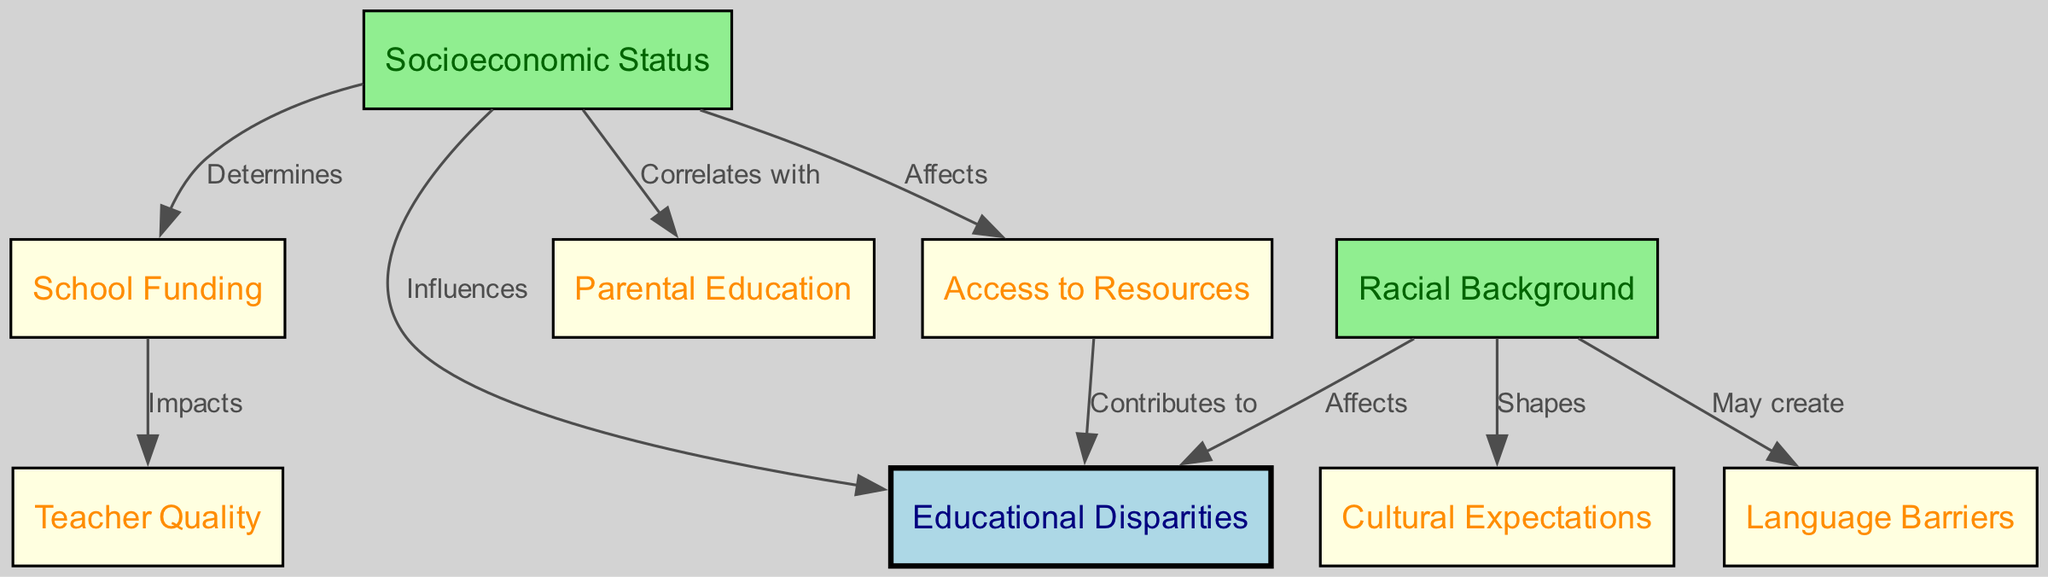What is the central theme of the diagram? The diagram's central theme is highlighted by the first node labeled "Educational Disparities," which signifies that all elements in the diagram are connected to this primary issue.
Answer: Educational Disparities How many nodes are there in the diagram? By counting the nodes listed in the data, there are nine distinct nodes, each representing various factors related to educational disparities.
Answer: Nine What factor does socioeconomic status influence? The diagram indicates that socioeconomic status has a direct influence on "Educational Disparities," establishing a causal relationship.
Answer: Educational Disparities Which node correlates with parental education? The edge from the "Socioeconomic Status" node to the "Parental Education" node indicates a correlating relationship, showcasing how socioeconomic factors relate to education levels of parents.
Answer: Parental Education What impacts school funding according to the diagram? The connection shows that socioeconomic status determines school funding, illustrating how these factors interact to shape education resources.
Answer: Socioeconomic Status What contributes to educational disparities? The diagram clearly states that "Access to Resources" contributes to "Educational Disparities," showing the importance of resource availability in educational equality.
Answer: Access to Resources How does racial background shape cultural expectations? The edge from "Racial Background" to "Cultural Expectations" indicates that one’s racial identity may influence the cultural norms or expectations surrounding education in different communities.
Answer: Cultural Expectations What creates language barriers? The diagram suggests that language barriers may be created due to the influences of racial backgrounds, indicating a potential source of educational challenges.
Answer: Racial Background What is the relationship between school funding and teacher quality? The edge connecting "School Funding" to "Teacher Quality" shows that the quality of teachers is impacted by how funding is allocated within schools.
Answer: Impacts 